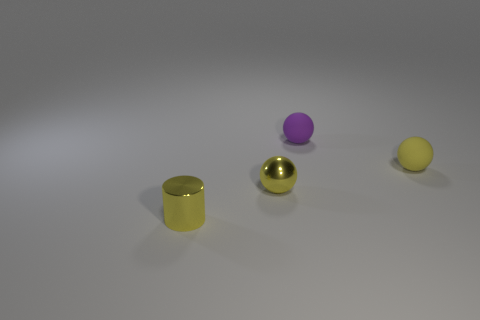Subtract 2 balls. How many balls are left? 1 Add 1 large purple rubber cylinders. How many objects exist? 5 Subtract all tiny shiny balls. How many balls are left? 2 Subtract all small rubber cylinders. Subtract all tiny purple spheres. How many objects are left? 3 Add 3 small purple matte spheres. How many small purple matte spheres are left? 4 Add 4 large yellow cylinders. How many large yellow cylinders exist? 4 Subtract all purple balls. How many balls are left? 2 Subtract 0 brown cylinders. How many objects are left? 4 Subtract all balls. How many objects are left? 1 Subtract all green balls. Subtract all cyan cylinders. How many balls are left? 3 